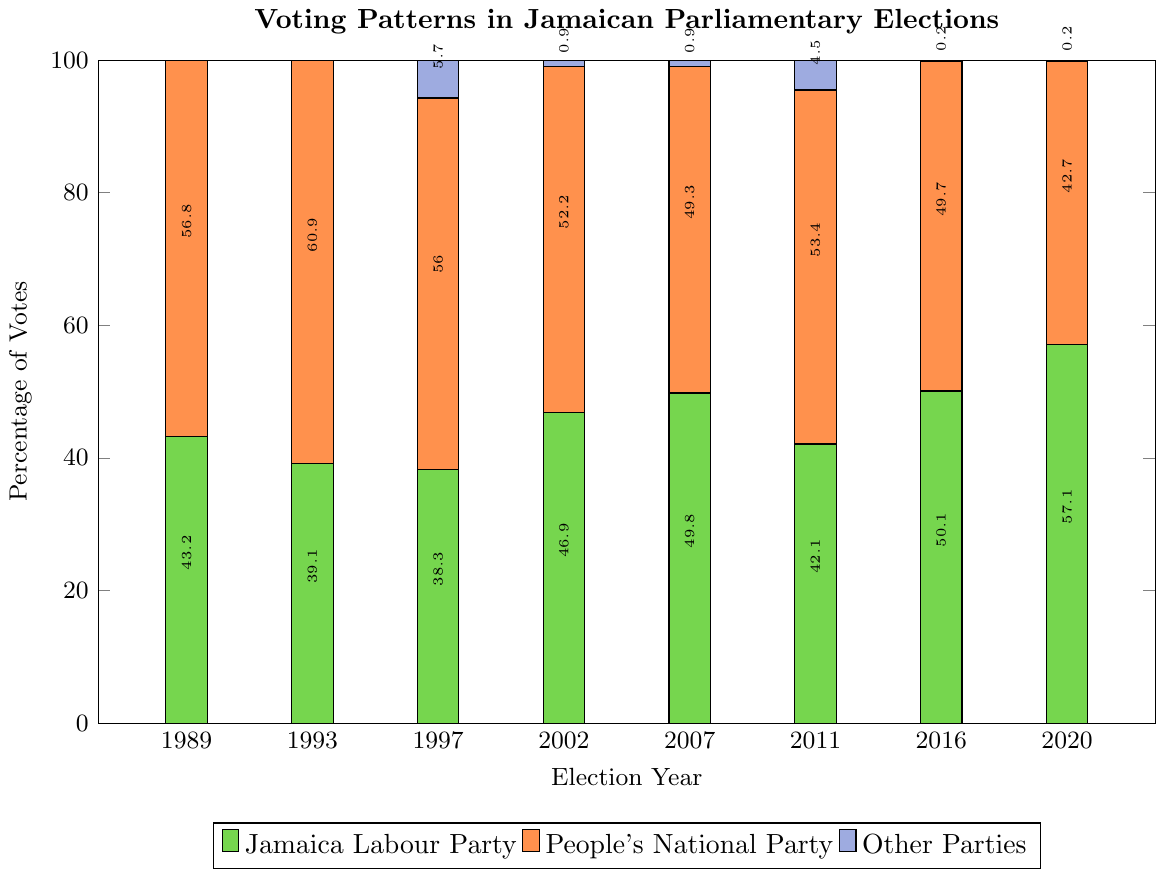What was the trend of the People's National Party (PNP) vote percentage from 1989 to 2020? First, visually follow the PNP's orange bars. Starting from 1989 to 2020, the percentages are: 56.8% in 1989, 60.9% in 1993, 56.0% in 1997, 52.2% in 2002, 49.3% in 2007, 53.4% in 2011, 49.7% in 2016, and 42.7% in 2020. You can see a general downward trend in the PNP vote percentage over the years.
Answer: Downward trend Which election year did the Jamaica Labour Party (JLP) have the highest percentage of votes? Visually examine the green bars for the JLP across all years. The highest bar is in 2020 with 57.1%.
Answer: 2020 In how many election years did "Other Parties" receive more than 1% of the votes? Follow the light purple bars, and note their heights. Only in 1997 and 2011 did "Other Parties" receive more than 1% of the votes.
Answer: 2 years What is the difference between the vote percentages of the JLP and PNP in 2020? In 2020, the JLP received 57.1% of the votes while the PNP received 42.7%. The difference is calculated by subtracting the PNP's percentage from the JLP's percentage: 57.1 - 42.7 = 14.4%.
Answer: 14.4% Did the People's National Party (PNP) ever receive the majority of the votes in any election year from 1989 to 2020? Visually inspect the heights of the orange bars (PNP). They all exceed 50% only in 1989 (56.8%), 1993 (60.9%), 1997 (56.0%), and 2011 (53.4%). Majority means more than 50%.
Answer: Yes By how much did the JLP's vote percentage change from 2002 to 2007? In 2002, the JLP had 46.9% of the votes, and in 2007, they had 49.8%. The change is calculated as 49.8 - 46.9 = 2.9%.
Answer: 2.9% Which political party had a steadier trend between the JLP and PNP from 1989 to 2020? Compare the visual heights of the green (JLP) and orange (PNP) bars over the years. The PNP bars show a more consistent decrease over the years, while the JLP bars fluctuate more notably. Therefore, the PNP shows a steadier trend.
Answer: PNP In 1997, how much did the "Other Parties" percentage contribute to the total votes? In 1997, "Other Parties" received 5.7%. This is directly given by the height of the light purple bar for the year 1997 in the plot.
Answer: 5.7% 